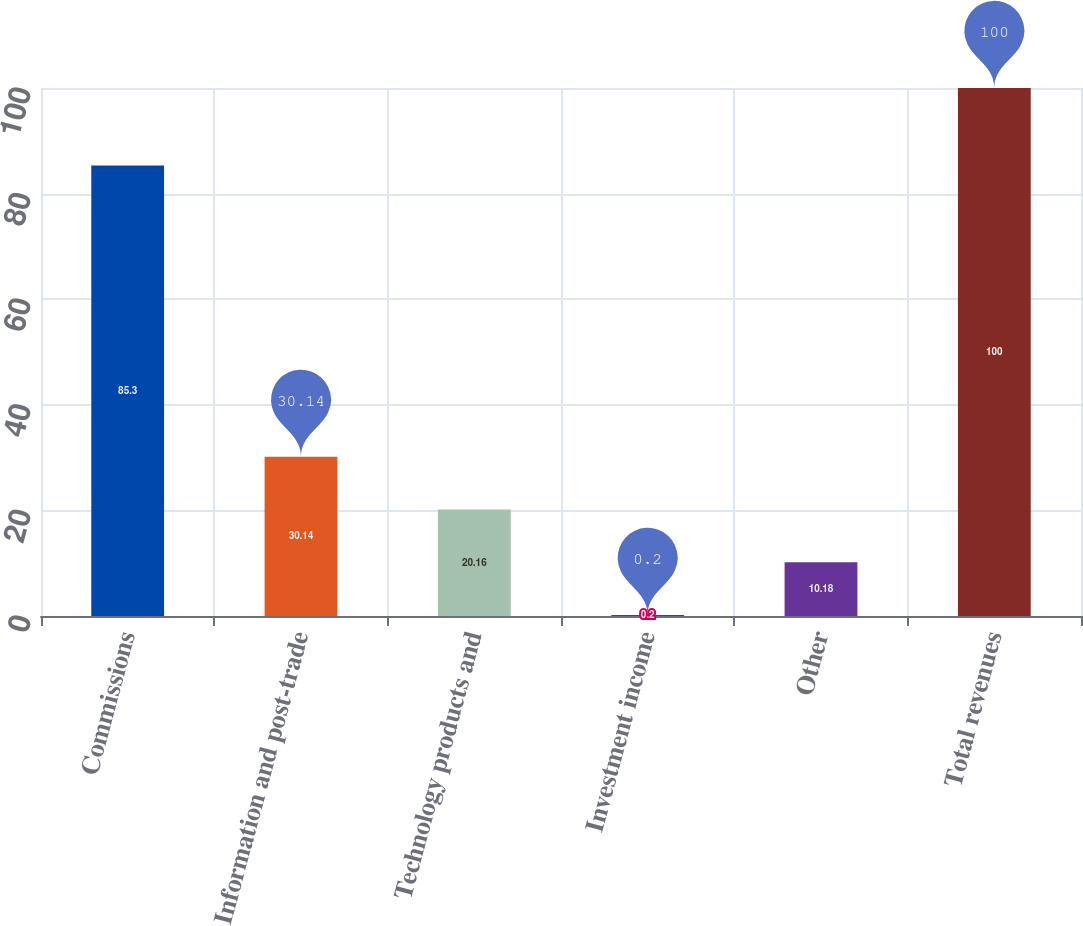Convert chart. <chart><loc_0><loc_0><loc_500><loc_500><bar_chart><fcel>Commissions<fcel>Information and post-trade<fcel>Technology products and<fcel>Investment income<fcel>Other<fcel>Total revenues<nl><fcel>85.3<fcel>30.14<fcel>20.16<fcel>0.2<fcel>10.18<fcel>100<nl></chart> 